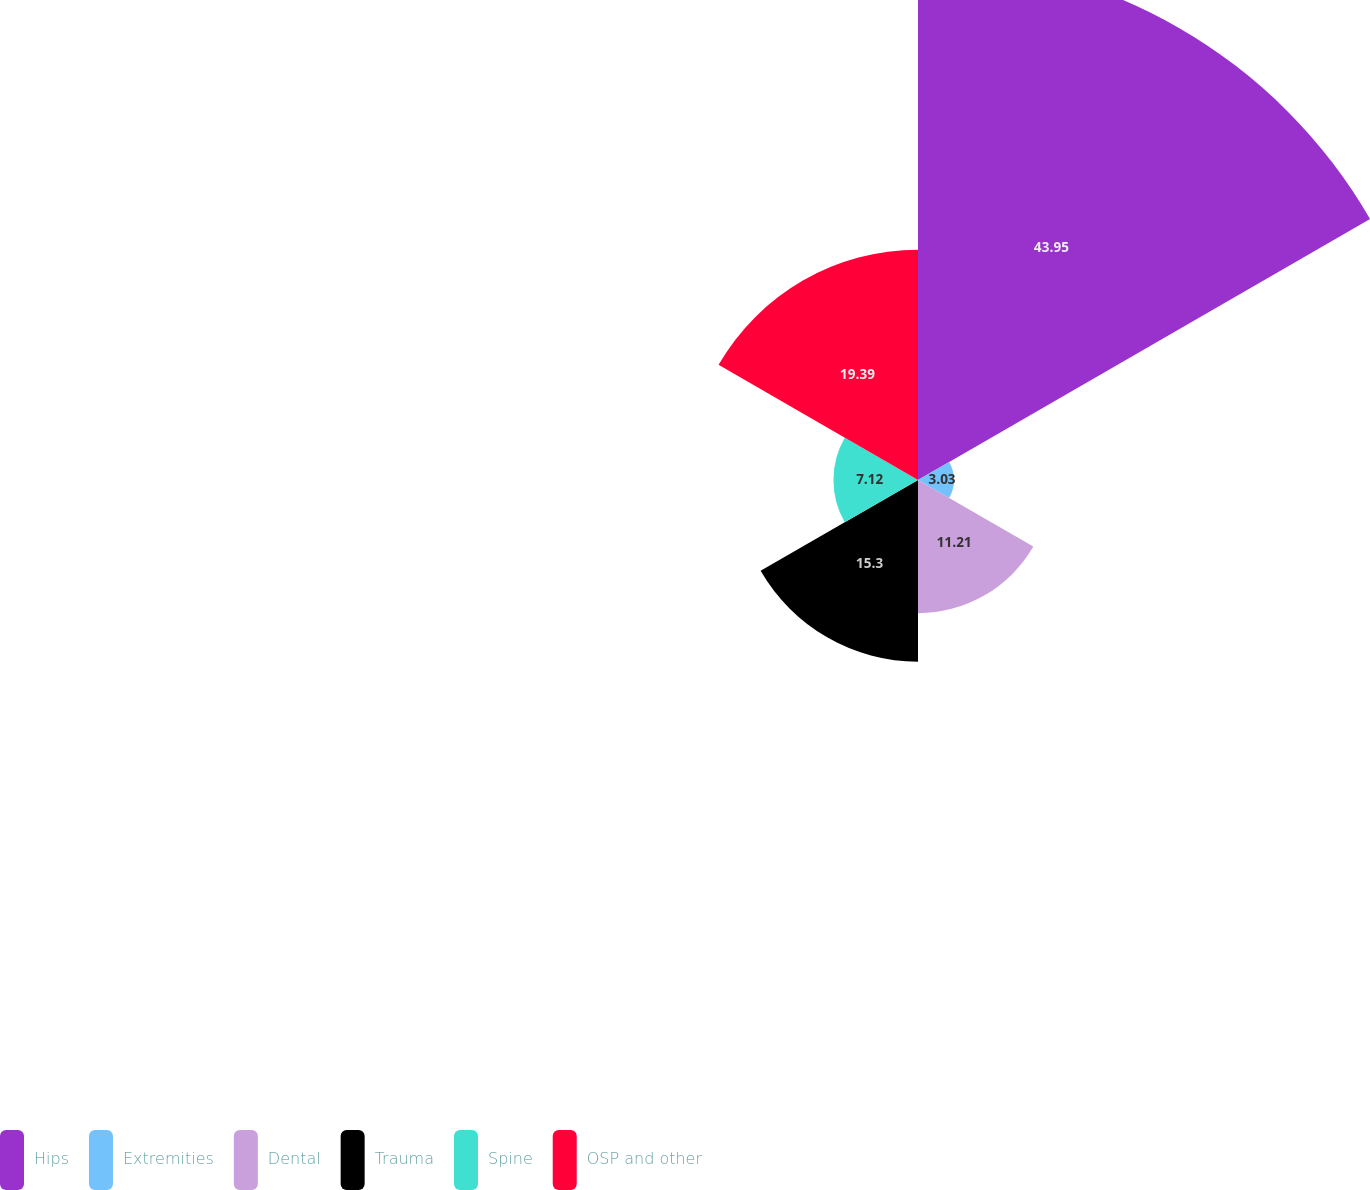<chart> <loc_0><loc_0><loc_500><loc_500><pie_chart><fcel>Hips<fcel>Extremities<fcel>Dental<fcel>Trauma<fcel>Spine<fcel>OSP and other<nl><fcel>43.95%<fcel>3.03%<fcel>11.21%<fcel>15.3%<fcel>7.12%<fcel>19.39%<nl></chart> 